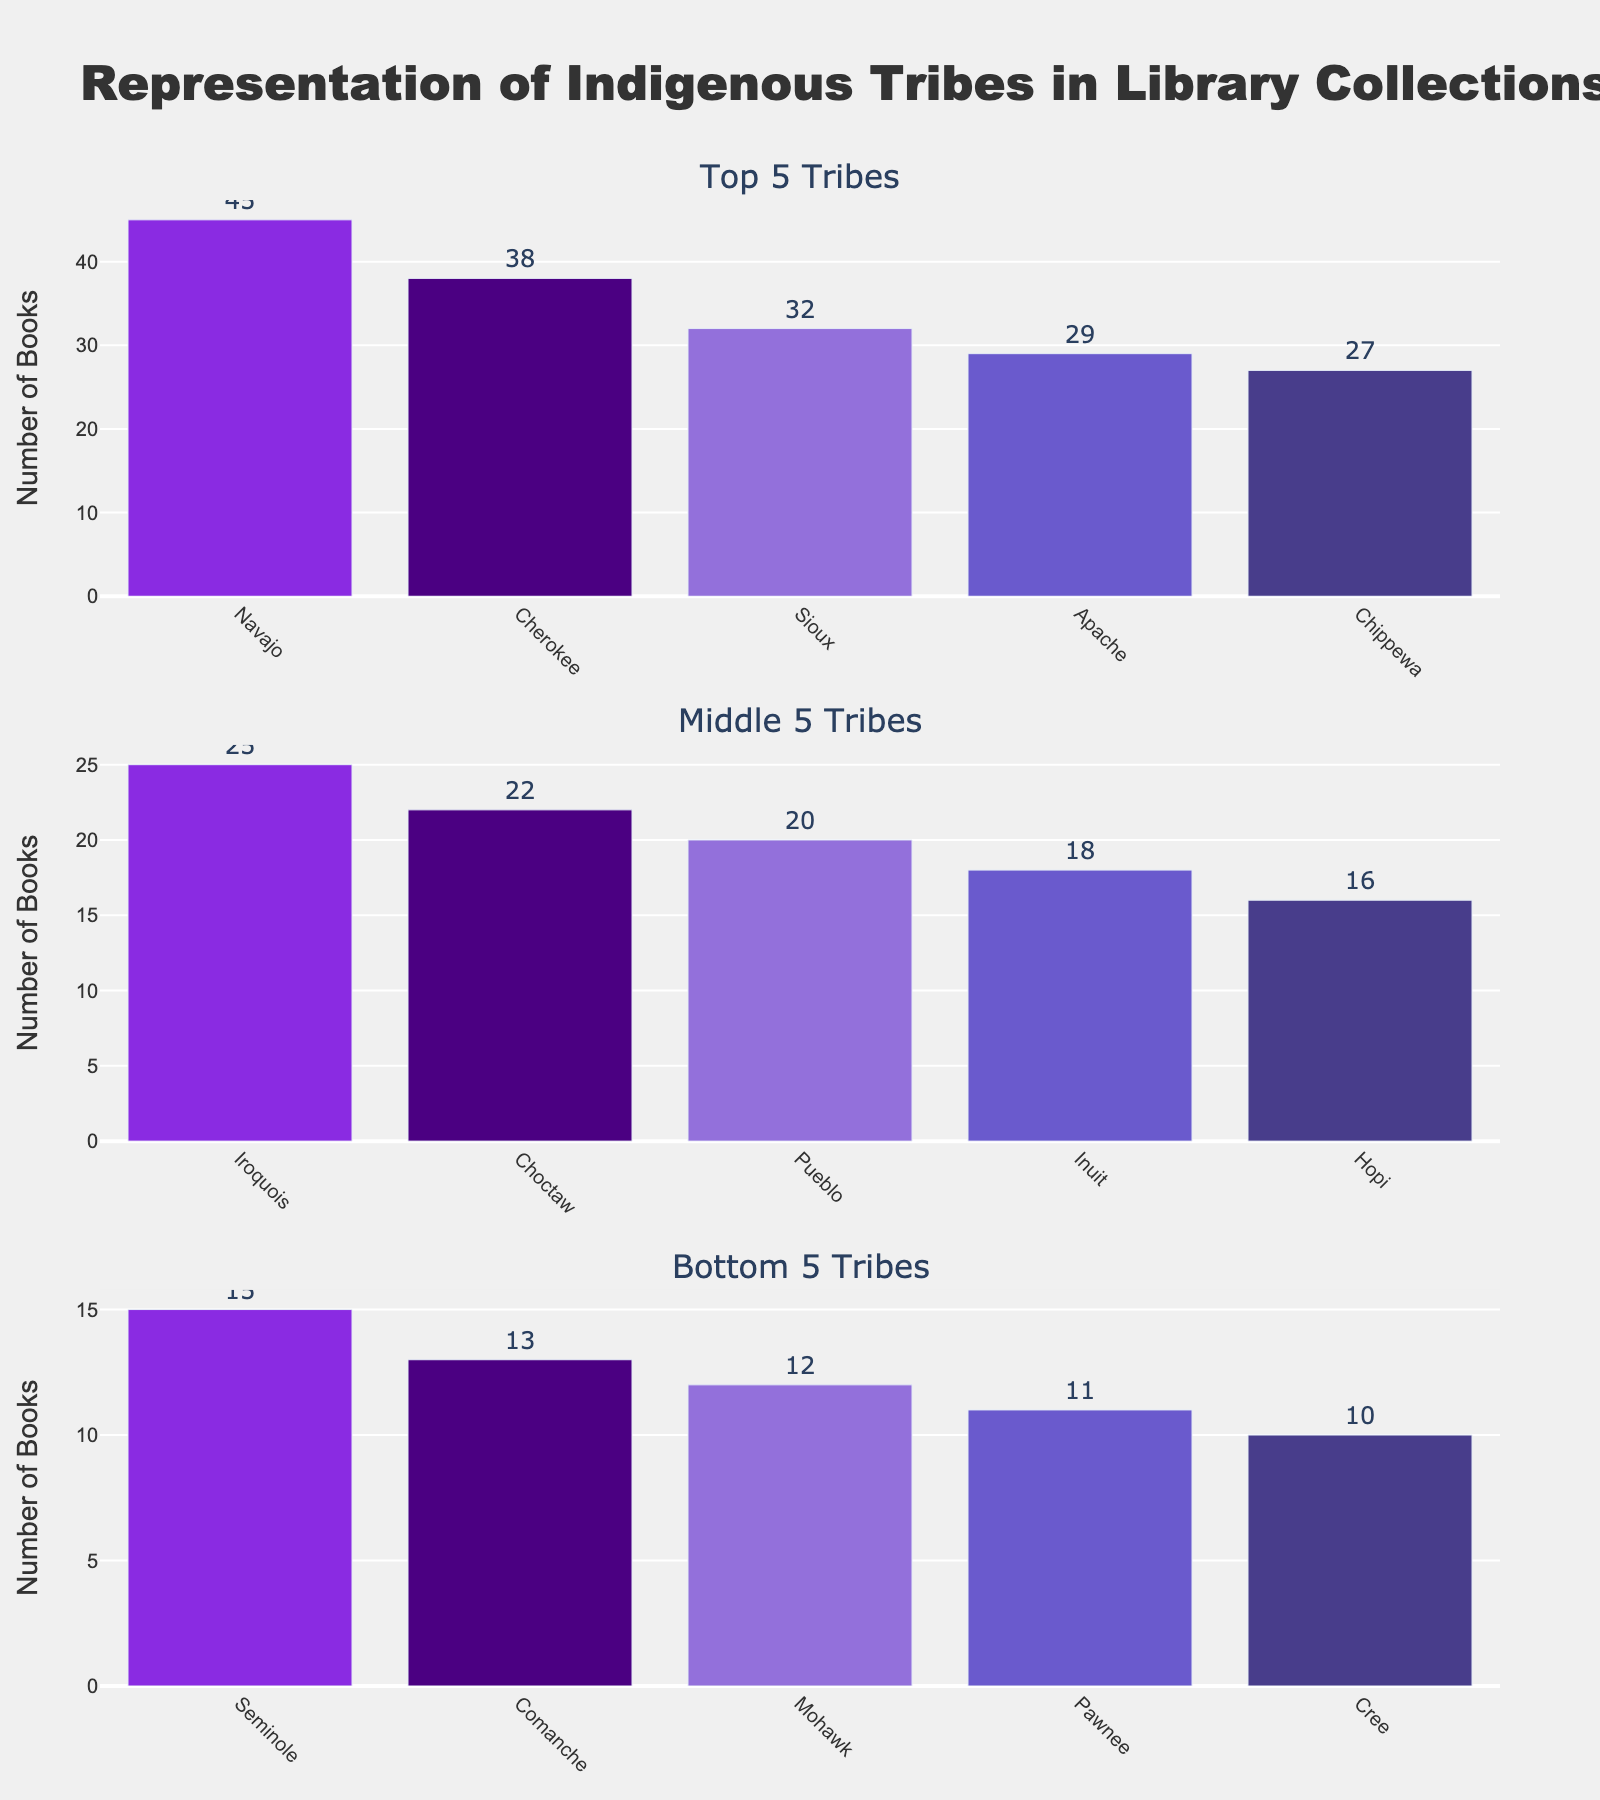Which tribe has the highest number of books in the library collection? The figure shows the top 5 tribes, with Navajo being the highest among them.
Answer: Navajo What is the total number of books for the middle 5 tribes? The middle 5 tribes are Choctaw, Pueblo, Inuit, Hopi, and Seminole. Adding their book counts: 22 + 20 + 18 + 16 + 15 = 91
Answer: 91 How many more books does the Navajo tribe have compared to the Sioux tribe? Navajo has 45 books, while Sioux has 32. The difference is 45 - 32 = 13
Answer: 13 Which tribe has the least number of books in the bottom 5 tribes? The bottom 5 tribes are Comanche, Mohawk, Pawnee, and Cree, with Cree having the least at 10 books.
Answer: Cree Among the middle 5 and bottom 5 tribes, which one has the highest number of books? The tribe with the highest number of books among the middle 5 and bottom 5 is Choctaw, with 22 books.
Answer: Choctaw Are there more books from the Apache or the Chippewa tribe? The figure shows that Apache has 29 books while Chippewa has 27 books.
Answer: Apache What is the average number of books for the top 5 tribes? Sum of books for the top 5 tribes (Navajo, Cherokee, Sioux, Apache, Chippewa) is 45 + 38 + 32 + 29 + 27 = 171. So, the average is 171/5 = 34.2
Answer: 34.2 How many tribes have at least 20 books in the library collection? From the figure, the tribes are Navajo, Cherokee, Sioux, Apache, Chippewa, Iroquois, Choctaw, Pueblo. There are 8 tribes with at least 20 books.
Answer: 8 Which tribes have fewer books than the Iroquois? Iroquois have 25 books. Tribes with fewer books shown in the subplots are Choctaw, Pueblo, Inuit, Hopi, Seminole, Comanche, Mohawk, Pawnee, and Cree.
Answer: Choctaw, Pueblo, Inuit, Hopi, Seminole, Comanche, Mohawk, Pawnee, Cree 